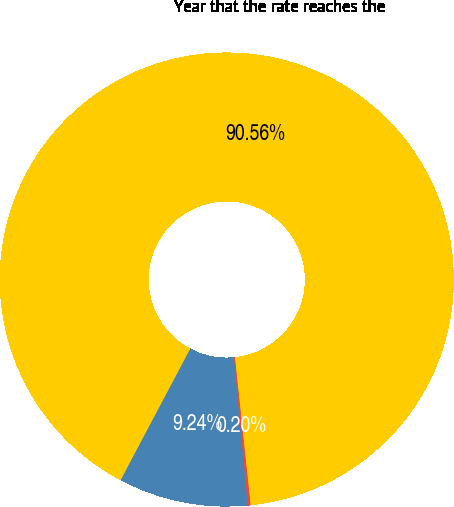Convert chart. <chart><loc_0><loc_0><loc_500><loc_500><pie_chart><fcel>Health care cost trend rate<fcel>Rate to which the cost trend<fcel>Year that the rate reaches the<nl><fcel>9.24%<fcel>0.2%<fcel>90.56%<nl></chart> 